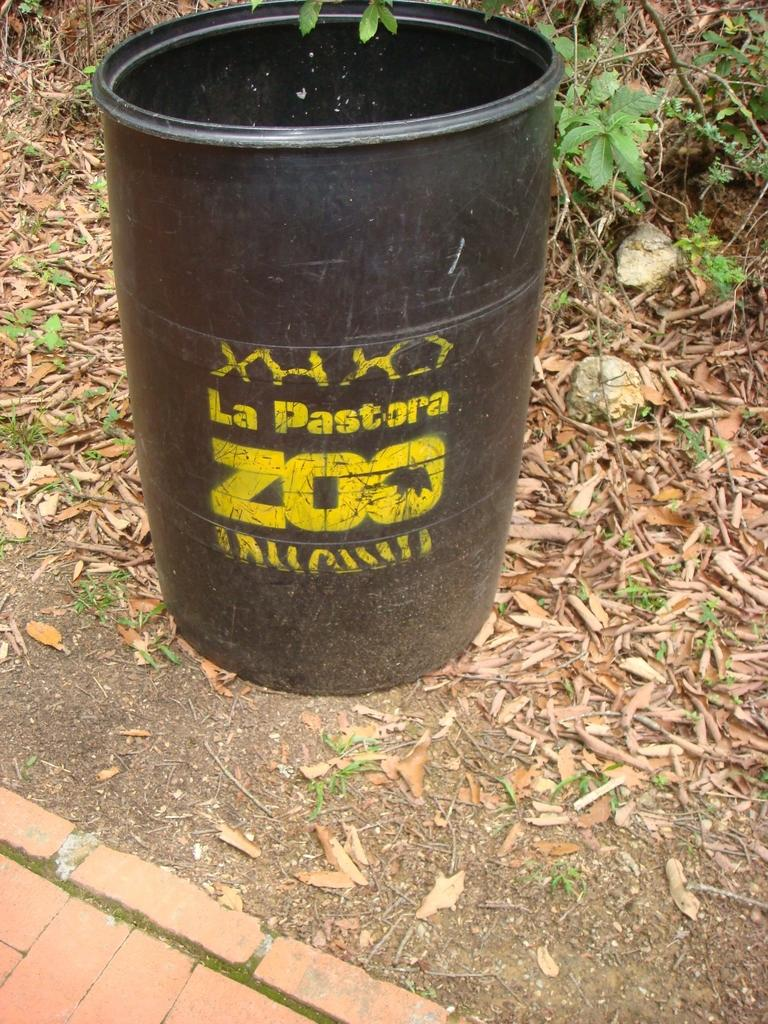<image>
Provide a brief description of the given image. A black bin has the La Pastora Zoo logo. 